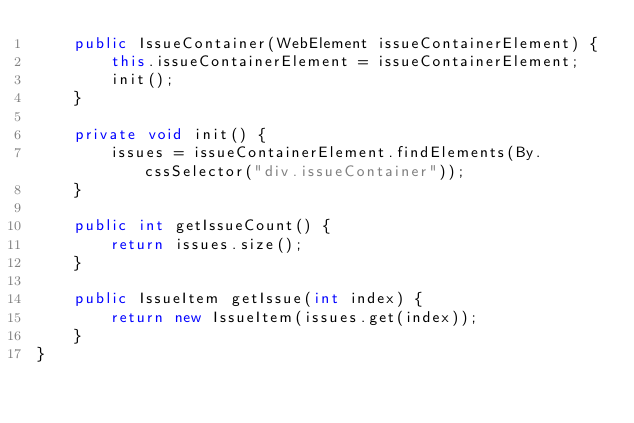<code> <loc_0><loc_0><loc_500><loc_500><_Java_>    public IssueContainer(WebElement issueContainerElement) {
        this.issueContainerElement = issueContainerElement;
        init();
    }

    private void init() {
        issues = issueContainerElement.findElements(By.cssSelector("div.issueContainer"));
    }

    public int getIssueCount() {
        return issues.size();
    }

    public IssueItem getIssue(int index) {
        return new IssueItem(issues.get(index));
    }
}
</code> 